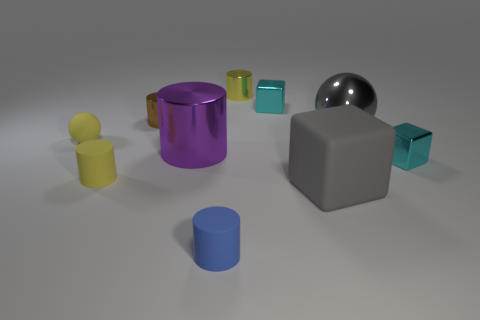How many matte blocks are on the right side of the gray metallic ball?
Give a very brief answer. 0. Are there an equal number of rubber spheres in front of the yellow shiny cylinder and yellow matte spheres on the right side of the purple object?
Your response must be concise. No. What is the size of the blue object that is the same shape as the big purple metallic object?
Ensure brevity in your answer.  Small. What shape is the cyan metal thing on the right side of the gray sphere?
Your response must be concise. Cube. Does the small blue cylinder that is right of the brown metal cylinder have the same material as the ball on the right side of the brown cylinder?
Your answer should be very brief. No. What shape is the blue object?
Give a very brief answer. Cylinder. Are there the same number of matte things behind the large sphere and small rubber things?
Give a very brief answer. No. What size is the rubber thing that is the same color as the big sphere?
Give a very brief answer. Large. Is there a big yellow sphere made of the same material as the brown cylinder?
Provide a short and direct response. No. There is a rubber object right of the blue cylinder; is it the same shape as the cyan object that is left of the large gray matte cube?
Your answer should be very brief. Yes. 